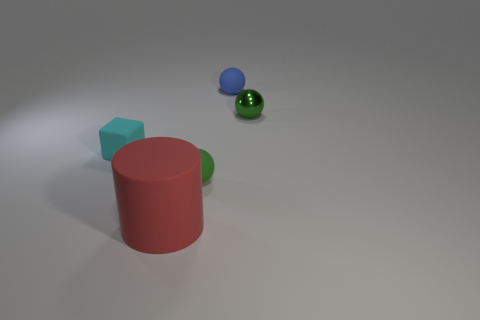Add 4 small yellow metal balls. How many objects exist? 9 Subtract all cylinders. How many objects are left? 4 Subtract 0 green blocks. How many objects are left? 5 Subtract all small balls. Subtract all blue metallic things. How many objects are left? 2 Add 1 green shiny balls. How many green shiny balls are left? 2 Add 3 shiny objects. How many shiny objects exist? 4 